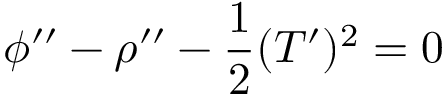<formula> <loc_0><loc_0><loc_500><loc_500>\phi ^ { \prime \prime } - \rho ^ { \prime \prime } - \frac { 1 } { 2 } ( T ^ { \prime } ) ^ { 2 } = 0</formula> 